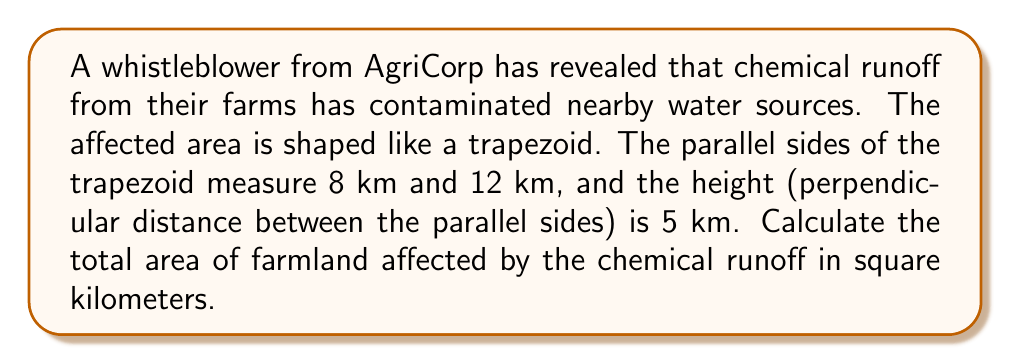Teach me how to tackle this problem. To solve this problem, we need to use the formula for the area of a trapezoid:

$$A = \frac{1}{2}(b_1 + b_2)h$$

Where:
$A$ = area of the trapezoid
$b_1$ and $b_2$ = lengths of the parallel sides
$h$ = height (perpendicular distance between the parallel sides)

Given:
$b_1 = 8$ km
$b_2 = 12$ km
$h = 5$ km

Let's substitute these values into the formula:

$$A = \frac{1}{2}(8 + 12) \times 5$$

First, add the parallel sides:
$$A = \frac{1}{2}(20) \times 5$$

Now multiply:
$$A = 10 \times 5 = 50$$

Therefore, the area of farmland affected by chemical runoff is 50 square kilometers.
Answer: $50$ square kilometers 